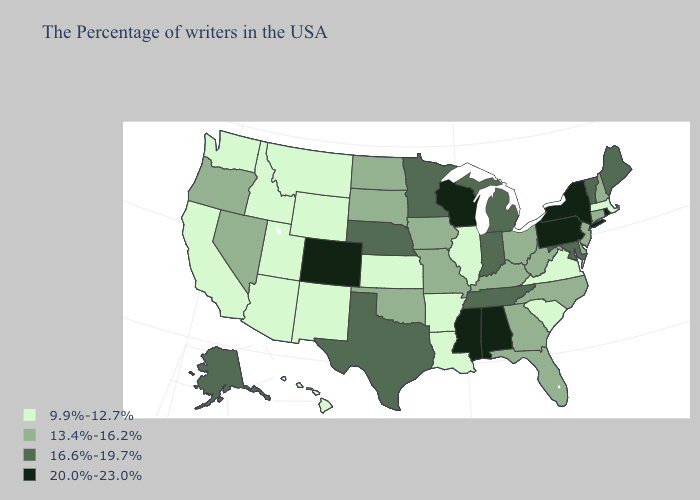Among the states that border Arkansas , which have the lowest value?
Write a very short answer. Louisiana. Name the states that have a value in the range 20.0%-23.0%?
Concise answer only. Rhode Island, New York, Pennsylvania, Alabama, Wisconsin, Mississippi, Colorado. What is the lowest value in states that border Oklahoma?
Keep it brief. 9.9%-12.7%. Name the states that have a value in the range 9.9%-12.7%?
Quick response, please. Massachusetts, Virginia, South Carolina, Illinois, Louisiana, Arkansas, Kansas, Wyoming, New Mexico, Utah, Montana, Arizona, Idaho, California, Washington, Hawaii. What is the value of Wyoming?
Short answer required. 9.9%-12.7%. Name the states that have a value in the range 13.4%-16.2%?
Concise answer only. New Hampshire, Connecticut, New Jersey, Delaware, North Carolina, West Virginia, Ohio, Florida, Georgia, Kentucky, Missouri, Iowa, Oklahoma, South Dakota, North Dakota, Nevada, Oregon. Among the states that border New Hampshire , which have the highest value?
Short answer required. Maine, Vermont. What is the lowest value in states that border Vermont?
Write a very short answer. 9.9%-12.7%. Does Oklahoma have the lowest value in the USA?
Answer briefly. No. Name the states that have a value in the range 16.6%-19.7%?
Quick response, please. Maine, Vermont, Maryland, Michigan, Indiana, Tennessee, Minnesota, Nebraska, Texas, Alaska. What is the value of Nebraska?
Concise answer only. 16.6%-19.7%. What is the highest value in states that border South Carolina?
Give a very brief answer. 13.4%-16.2%. Name the states that have a value in the range 16.6%-19.7%?
Be succinct. Maine, Vermont, Maryland, Michigan, Indiana, Tennessee, Minnesota, Nebraska, Texas, Alaska. Name the states that have a value in the range 13.4%-16.2%?
Give a very brief answer. New Hampshire, Connecticut, New Jersey, Delaware, North Carolina, West Virginia, Ohio, Florida, Georgia, Kentucky, Missouri, Iowa, Oklahoma, South Dakota, North Dakota, Nevada, Oregon. Does Kentucky have the lowest value in the USA?
Quick response, please. No. 